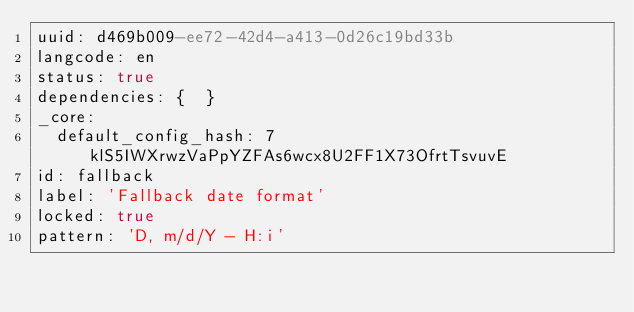<code> <loc_0><loc_0><loc_500><loc_500><_YAML_>uuid: d469b009-ee72-42d4-a413-0d26c19bd33b
langcode: en
status: true
dependencies: {  }
_core:
  default_config_hash: 7klS5IWXrwzVaPpYZFAs6wcx8U2FF1X73OfrtTsvuvE
id: fallback
label: 'Fallback date format'
locked: true
pattern: 'D, m/d/Y - H:i'
</code> 